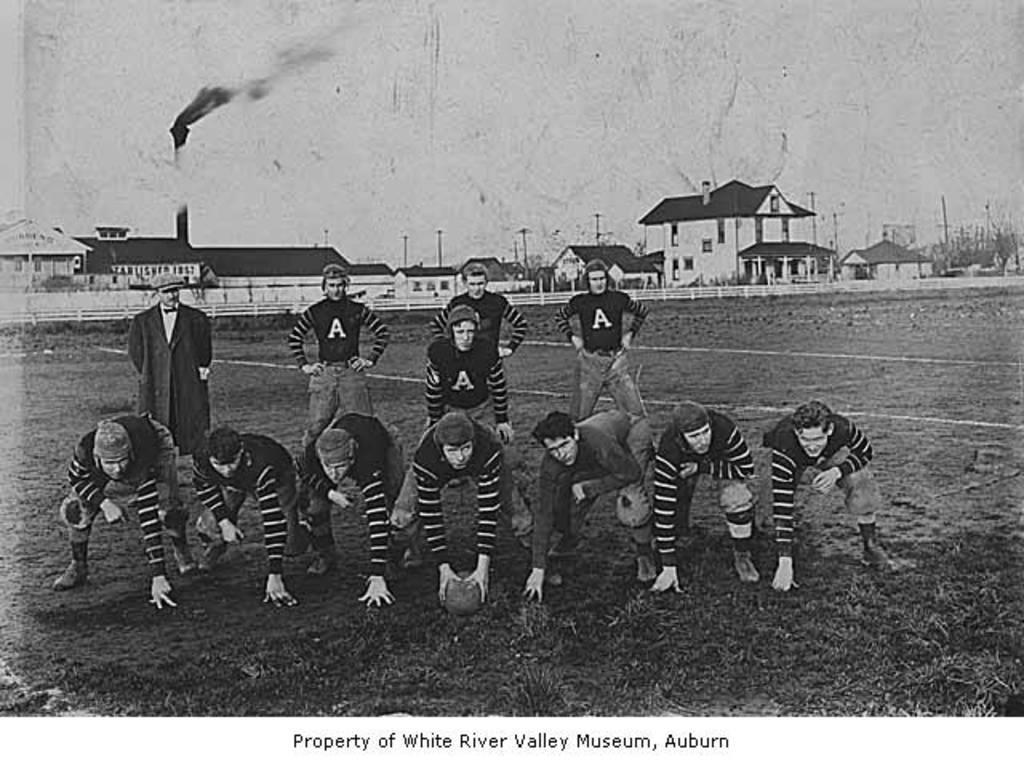In one or two sentences, can you explain what this image depicts? It is a black and white image. In this image we can see the players. We can also see a ball, grass and also the play ground. In the background we can see the houses, smoke tower and also a barrier. We can also see the sky and at the bottom we can see the text. 